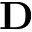<formula> <loc_0><loc_0><loc_500><loc_500>D</formula> 